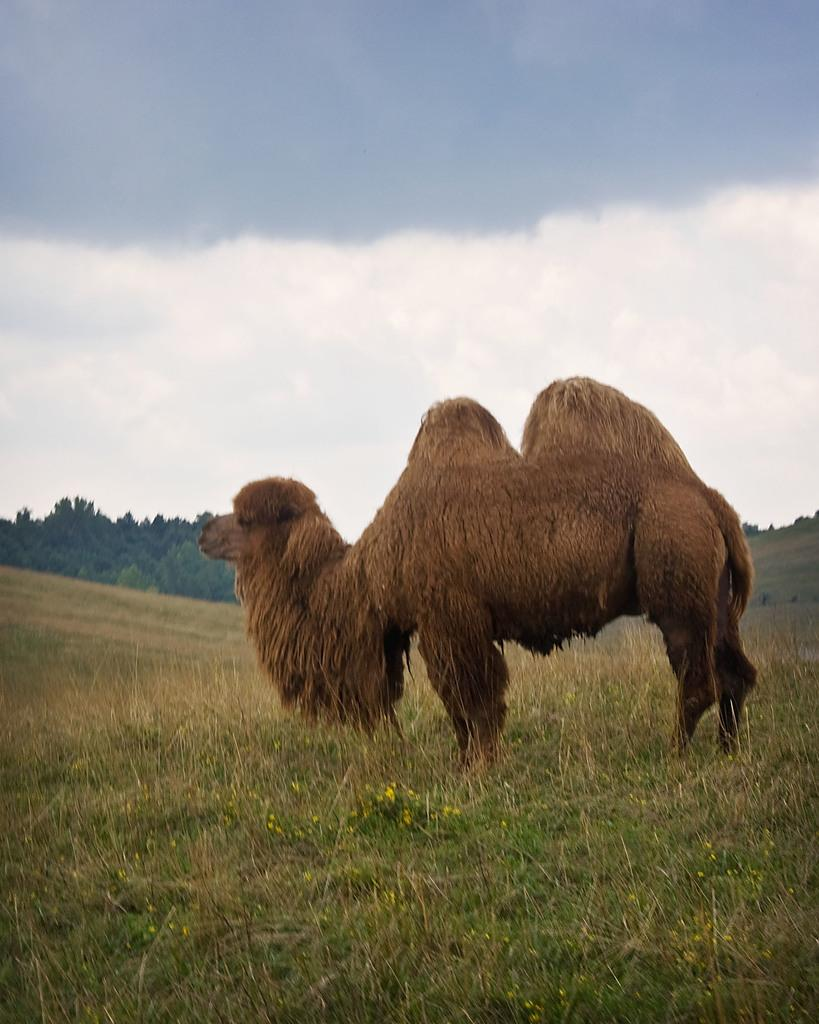What type of creature is in the image? There is an animal in the image. Where is the animal located? The animal is standing on the grass. What can be seen in the background of the image? There are trees visible in the background of the image. How many apples can be seen on the animal's back in the image? There are no apples present in the image, and therefore none can be seen on the animal's back. 